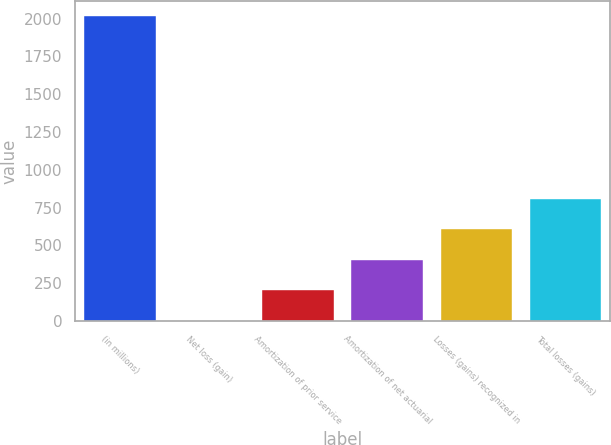<chart> <loc_0><loc_0><loc_500><loc_500><bar_chart><fcel>(in millions)<fcel>Net loss (gain)<fcel>Amortization of prior service<fcel>Amortization of net actuarial<fcel>Losses (gains) recognized in<fcel>Total losses (gains)<nl><fcel>2016<fcel>3<fcel>204.3<fcel>405.6<fcel>606.9<fcel>808.2<nl></chart> 